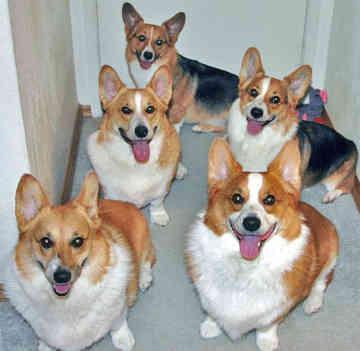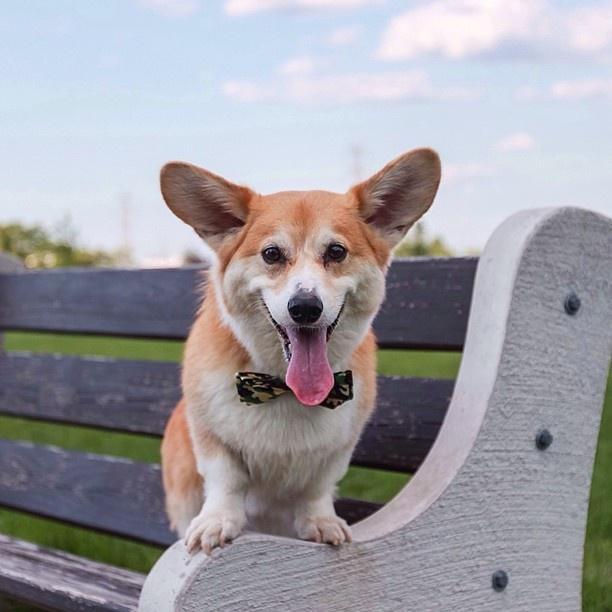The first image is the image on the left, the second image is the image on the right. For the images displayed, is the sentence "There is a dog wearing a bow tie and nothing else." factually correct? Answer yes or no. Yes. The first image is the image on the left, the second image is the image on the right. Examine the images to the left and right. Is the description "The left image features one live dog posed with at least one stuffed animal figure, and the right image shows one dog that is not wearing any human-type attire." accurate? Answer yes or no. No. 